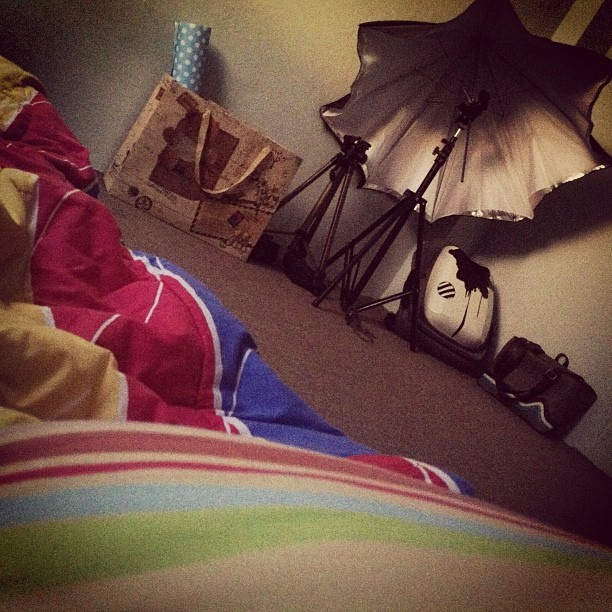Describe the objects in this image and their specific colors. I can see bed in black, maroon, brown, tan, and gray tones, umbrella in black, maroon, gray, and tan tones, handbag in black, maroon, and brown tones, and handbag in black and gray tones in this image. 